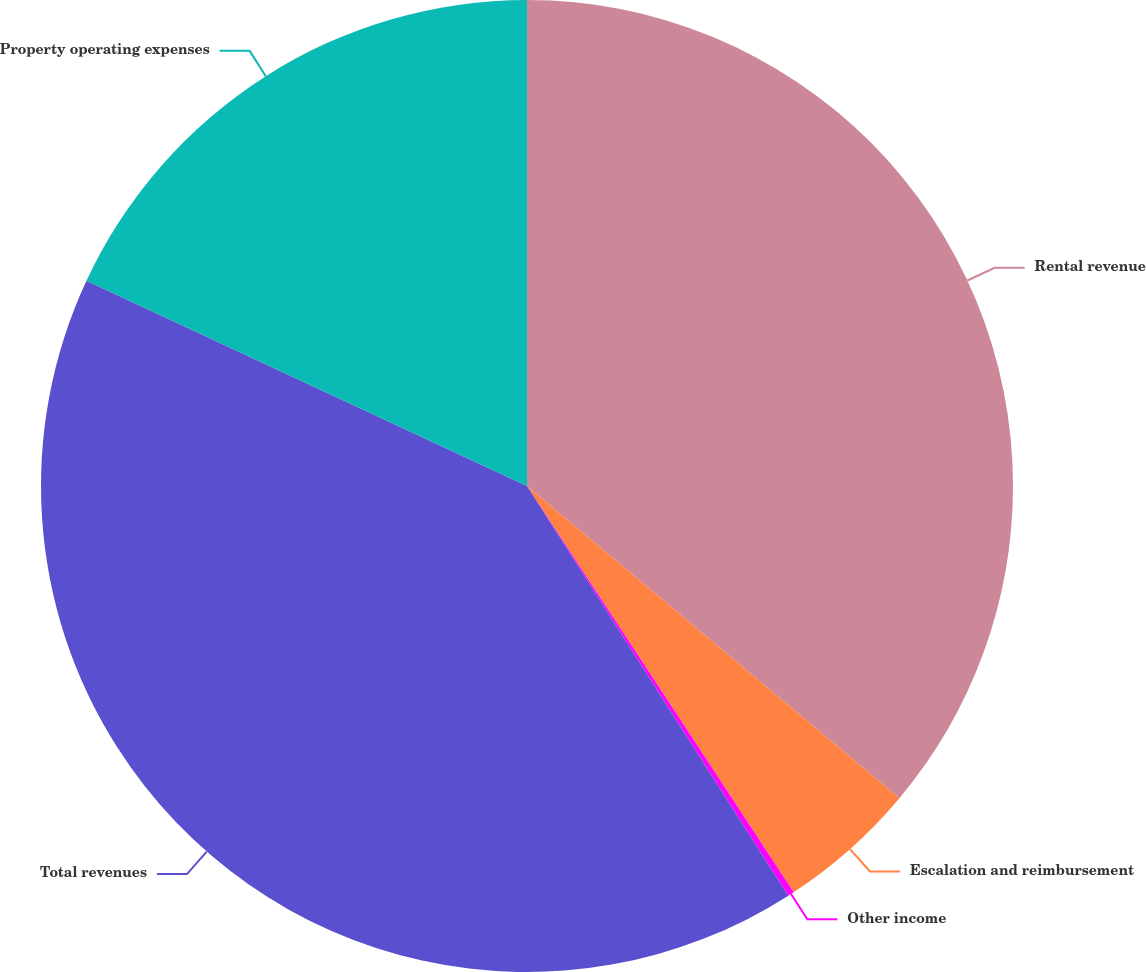<chart> <loc_0><loc_0><loc_500><loc_500><pie_chart><fcel>Rental revenue<fcel>Escalation and reimbursement<fcel>Other income<fcel>Total revenues<fcel>Property operating expenses<nl><fcel>36.1%<fcel>4.65%<fcel>0.21%<fcel>40.97%<fcel>18.06%<nl></chart> 